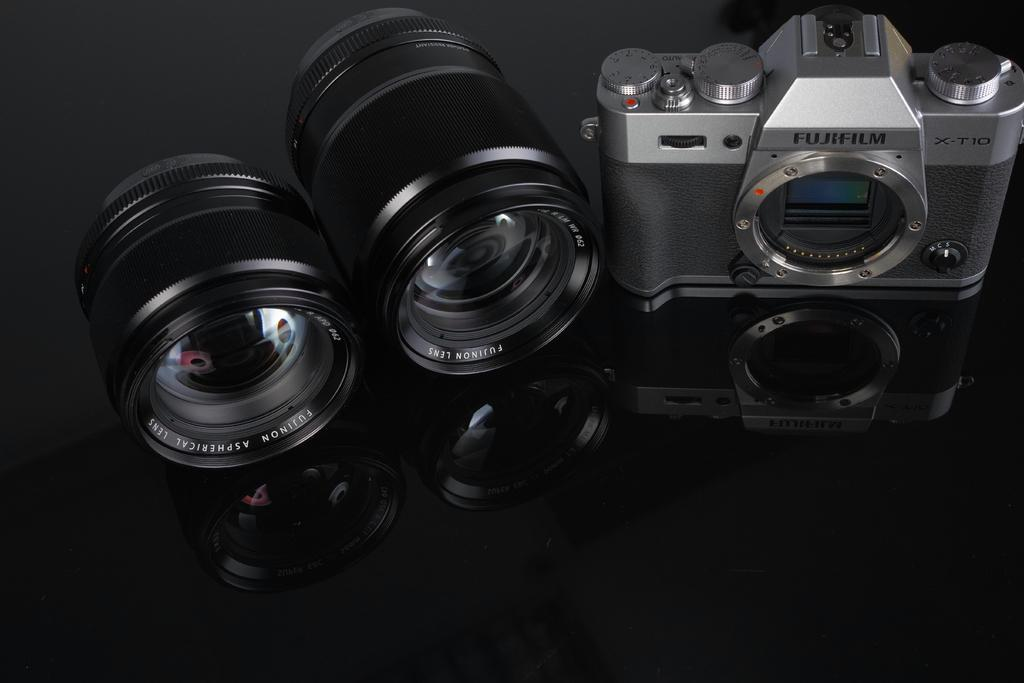What is the main subject of the image? The main subject of the image is a camera. Can you describe the camera in more detail? Yes, there are two different lenses of the camera in the image. What is the reflection on the surface in the image? The camera and lenses are reflected on a glass or marble surface. What type of island can be seen in the background of the image? There is no island present in the image; it features a camera and lenses reflected on a surface. 